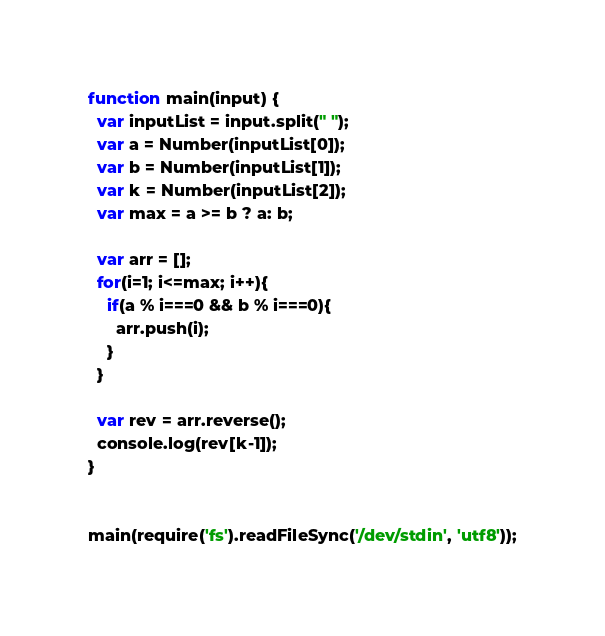<code> <loc_0><loc_0><loc_500><loc_500><_JavaScript_>function main(input) {
  var inputList = input.split(" ");
  var a = Number(inputList[0]);
  var b = Number(inputList[1]);
  var k = Number(inputList[2]);
  var max = a >= b ? a: b;

  var arr = [];
  for(i=1; i<=max; i++){
    if(a % i===0 && b % i===0){
      arr.push(i);
    }
  }

  var rev = arr.reverse();
  console.log(rev[k-1]);
}


main(require('fs').readFileSync('/dev/stdin', 'utf8'));
</code> 